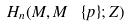Convert formula to latex. <formula><loc_0><loc_0><loc_500><loc_500>H _ { n } ( M , M \ \{ p \} ; Z )</formula> 